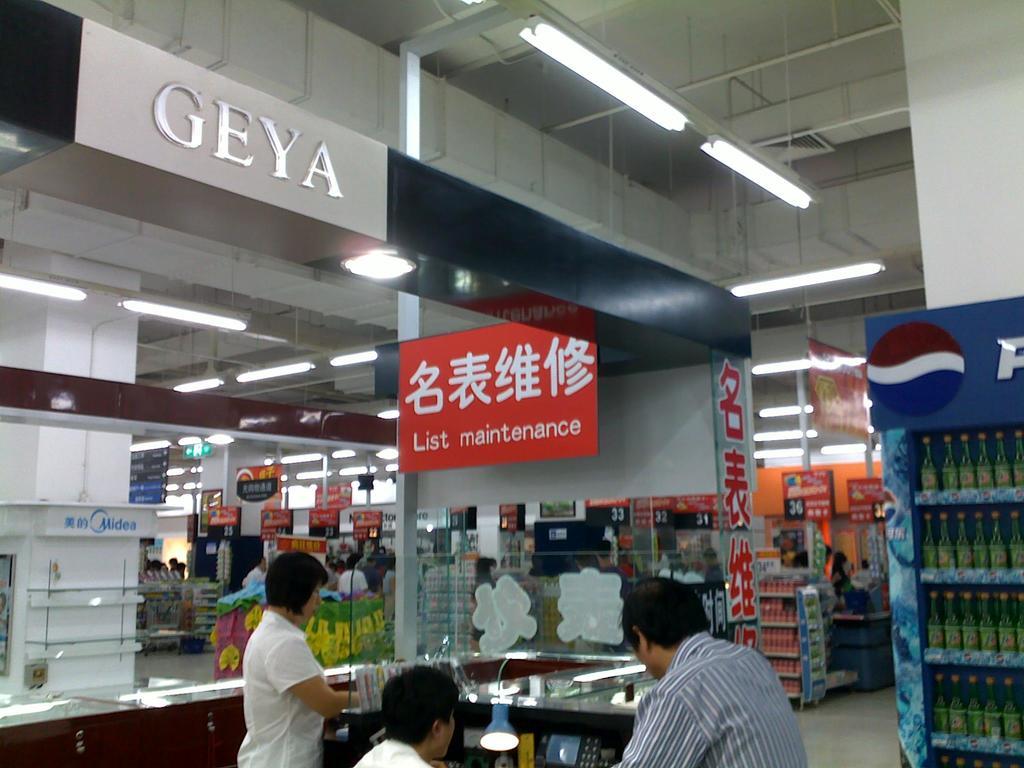What do the silver letters say?
Your response must be concise. Geya. What does the red sign say?
Provide a succinct answer. List maintenance. 